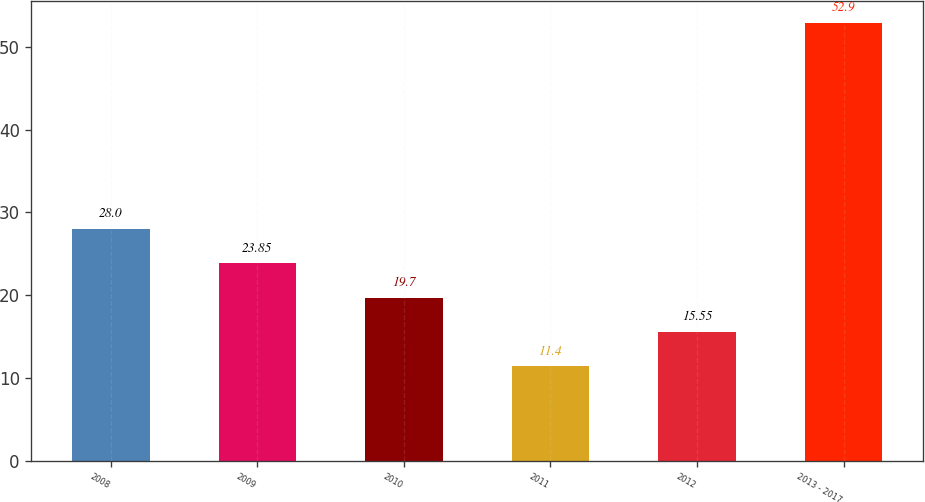Convert chart to OTSL. <chart><loc_0><loc_0><loc_500><loc_500><bar_chart><fcel>2008<fcel>2009<fcel>2010<fcel>2011<fcel>2012<fcel>2013 - 2017<nl><fcel>28<fcel>23.85<fcel>19.7<fcel>11.4<fcel>15.55<fcel>52.9<nl></chart> 